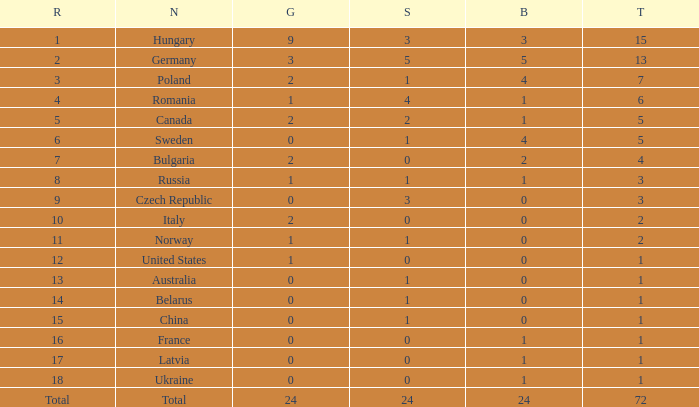What average silver has belarus as the nation, with a total less than 1? None. 